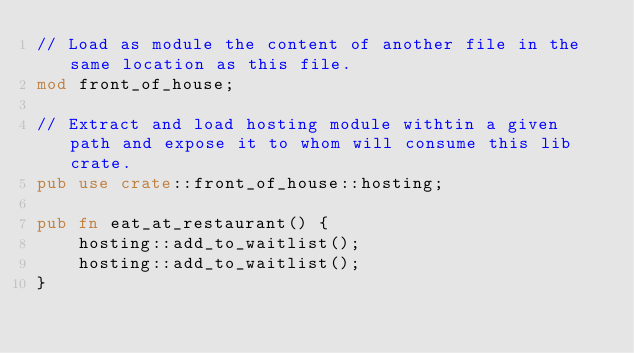<code> <loc_0><loc_0><loc_500><loc_500><_Rust_>// Load as module the content of another file in the same location as this file.
mod front_of_house;

// Extract and load hosting module withtin a given path and expose it to whom will consume this lib crate.
pub use crate::front_of_house::hosting;

pub fn eat_at_restaurant() {
    hosting::add_to_waitlist();
    hosting::add_to_waitlist();
}</code> 